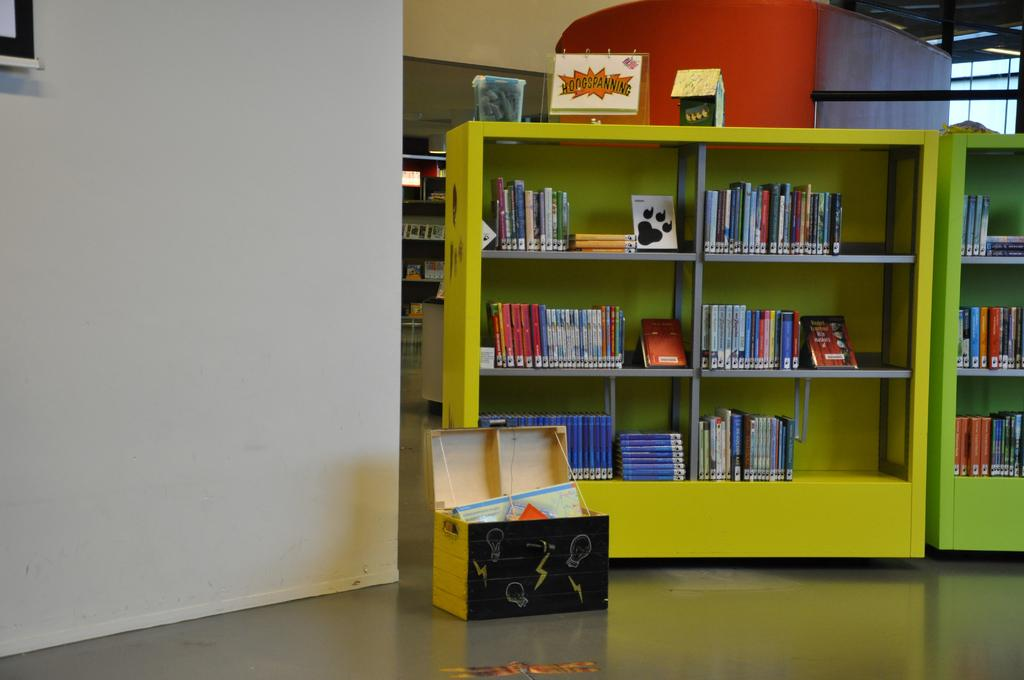What type of furniture is on the floor in the image? There are metal cabinets on the floor. What can be found on the metal cabinets? There are books on the metal shelves. What else is on the floor in the image? There is a suitcase box on the floor. What type of zipper can be seen on the beast in the image? There is no beast or zipper present in the image. 